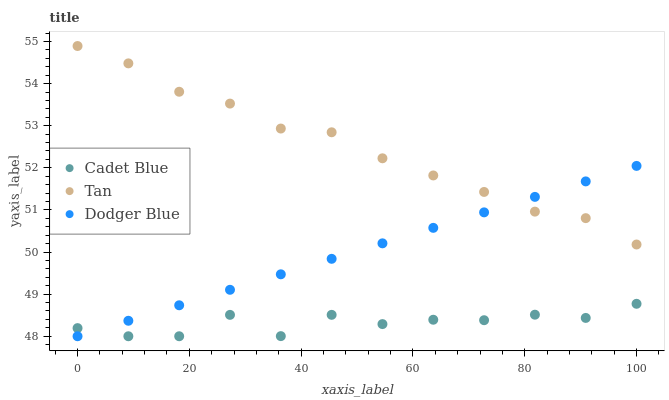Does Cadet Blue have the minimum area under the curve?
Answer yes or no. Yes. Does Tan have the maximum area under the curve?
Answer yes or no. Yes. Does Dodger Blue have the minimum area under the curve?
Answer yes or no. No. Does Dodger Blue have the maximum area under the curve?
Answer yes or no. No. Is Dodger Blue the smoothest?
Answer yes or no. Yes. Is Cadet Blue the roughest?
Answer yes or no. Yes. Is Cadet Blue the smoothest?
Answer yes or no. No. Is Dodger Blue the roughest?
Answer yes or no. No. Does Cadet Blue have the lowest value?
Answer yes or no. Yes. Does Tan have the highest value?
Answer yes or no. Yes. Does Dodger Blue have the highest value?
Answer yes or no. No. Is Cadet Blue less than Tan?
Answer yes or no. Yes. Is Tan greater than Cadet Blue?
Answer yes or no. Yes. Does Tan intersect Dodger Blue?
Answer yes or no. Yes. Is Tan less than Dodger Blue?
Answer yes or no. No. Is Tan greater than Dodger Blue?
Answer yes or no. No. Does Cadet Blue intersect Tan?
Answer yes or no. No. 